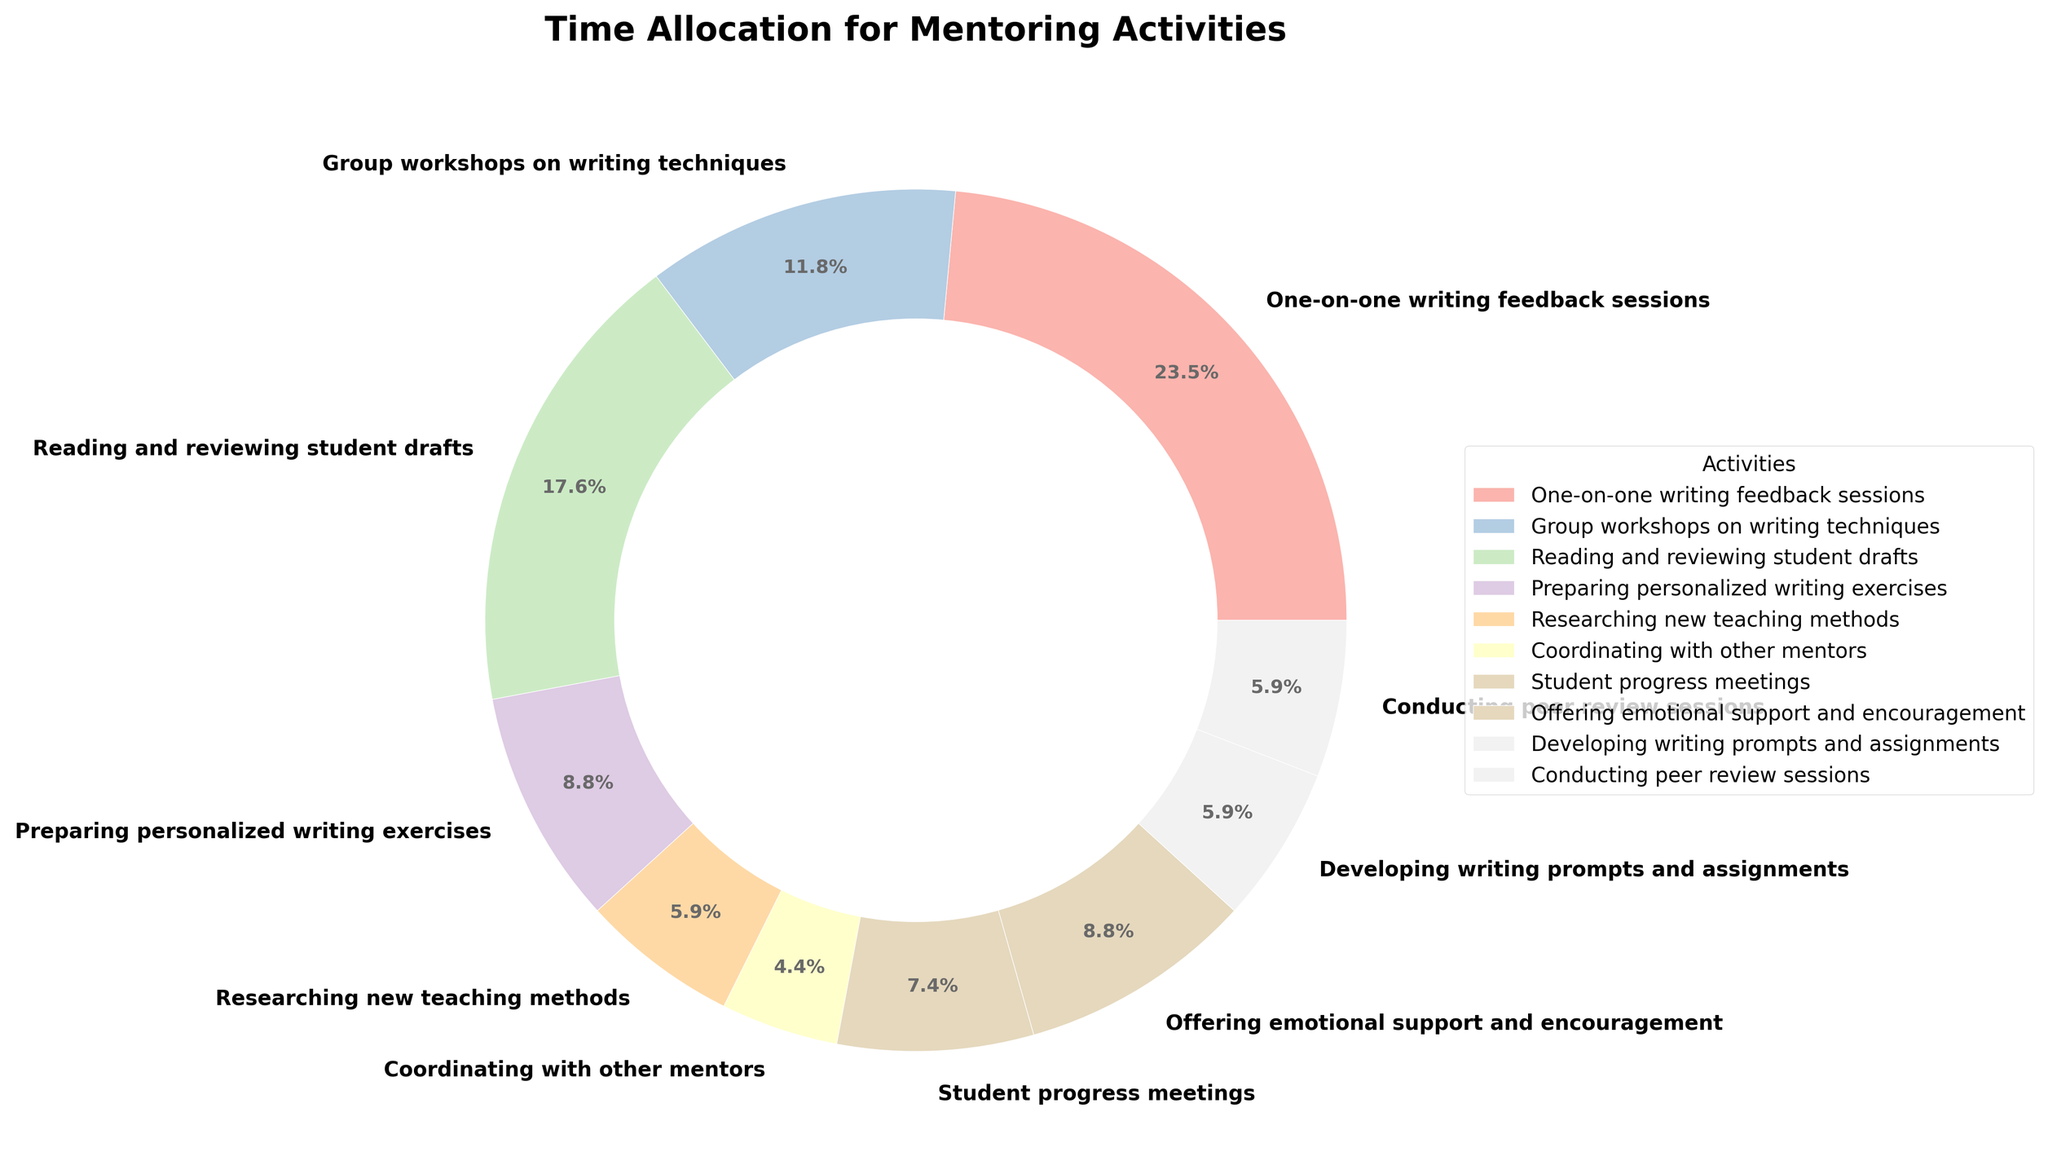What's the activity with the highest time allocation? The chart shows different activities and their corresponding percentage of time allocation. By identifying the activity with the biggest pie slice, we see that "One-on-one writing feedback sessions" has the largest portion.
Answer: One-on-one writing feedback sessions What percentage of time is spent on "Group workshops on writing techniques"? Refer to the part of the pie chart labeled "Group workshops on writing techniques" and find the percentage indicated. The slice is labeled with a percentage value.
Answer: 10.3% Which activity takes up more time: "Reading and reviewing student drafts" or "Offering emotional support and encouragement"? Compare the pie slices for "Reading and reviewing student drafts" and "Offering emotional support and encouragement." "Reading and reviewing student drafts" has a larger slice.
Answer: Reading and reviewing student drafts What is the total time allocated to "One-on-one writing feedback sessions" and "Reading and reviewing student drafts"? Sum the percentages of the slices labeled "One-on-one writing feedback sessions" (27.6%) and "Reading and reviewing student drafts" (20.7%). 27.6% + 20.7% = 48.3%.
Answer: 48.3% How does the time allocation for "Researching new teaching methods," compare to that of "Student progress meetings" and "Conducting peer review sessions" combined? Refer to the slices for "Researching new teaching methods" (6.9%), "Student progress meetings" (8.6%), and "Conducting peer review sessions" (6.9%). Compare 6.9% to the sum of 8.6% + 6.9% = 15.5%. "Researching new teaching methods" is smaller.
Answer: Less than Which activities take up a combined 20% of the time? Look for slices that can add up their percentages to a total close to 20%. "Student progress meetings" (8.6%) and "Conducting peer review sessions" (6.9%) together amount to 8.6% + 6.9% = 15.5%. Including "Researching new teaching methods" (6.9%) brings the total to around 20%.
Answer: Student progress meetings, Conducting peer review sessions, Researching new teaching methods What visual attribute distinguishes "One-on-one writing feedback sessions" from the rest of the activities? The visual attribute that can be examined is the size or the percentage of the pie slice. "One-on-one writing feedback sessions" has the largest portion of the pie.
Answer: Largest portion What is the total time allocated to "Developing writing prompts and assignments" and "Conducting peer review sessions"? Sum the percentages of the slices labeled "Developing writing prompts and assignments" (6.9%) and "Conducting peer review sessions" (6.9%). 6.9% + 6.9% = 13.8%.
Answer: 13.8% Is there an activity assigned exactly 6.9% of the time? If so, what is it? Check the pie chart for any slice labeled with exactly 6.9%. Both "Researching new teaching methods" and "Conducting peer review sessions" have this percentage.
Answer: Researching new teaching methods, Conducting peer review sessions Which activities account for more than 10% of the time each? Identify slices that have a percentage label greater than 10%. "One-on-one writing feedback sessions" (27.6%) and "Reading and reviewing student drafts" (20.7%) both fit this criterion.
Answer: One-on-one writing feedback sessions, Reading and reviewing student drafts 